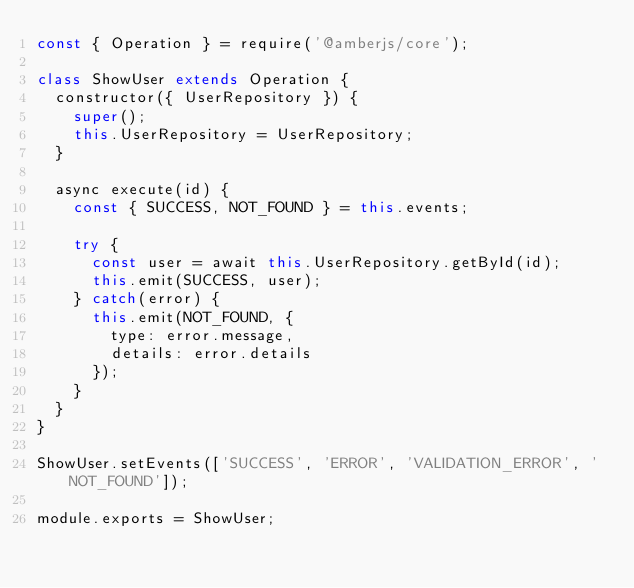Convert code to text. <code><loc_0><loc_0><loc_500><loc_500><_JavaScript_>const { Operation } = require('@amberjs/core');

class ShowUser extends Operation {
  constructor({ UserRepository }) {
    super();
    this.UserRepository = UserRepository;
  }

  async execute(id) {
    const { SUCCESS, NOT_FOUND } = this.events;

    try {
      const user = await this.UserRepository.getById(id);
      this.emit(SUCCESS, user);
    } catch(error) {
      this.emit(NOT_FOUND, {
        type: error.message,
        details: error.details
      });
    }
  }
}

ShowUser.setEvents(['SUCCESS', 'ERROR', 'VALIDATION_ERROR', 'NOT_FOUND']);

module.exports = ShowUser;
    
</code> 